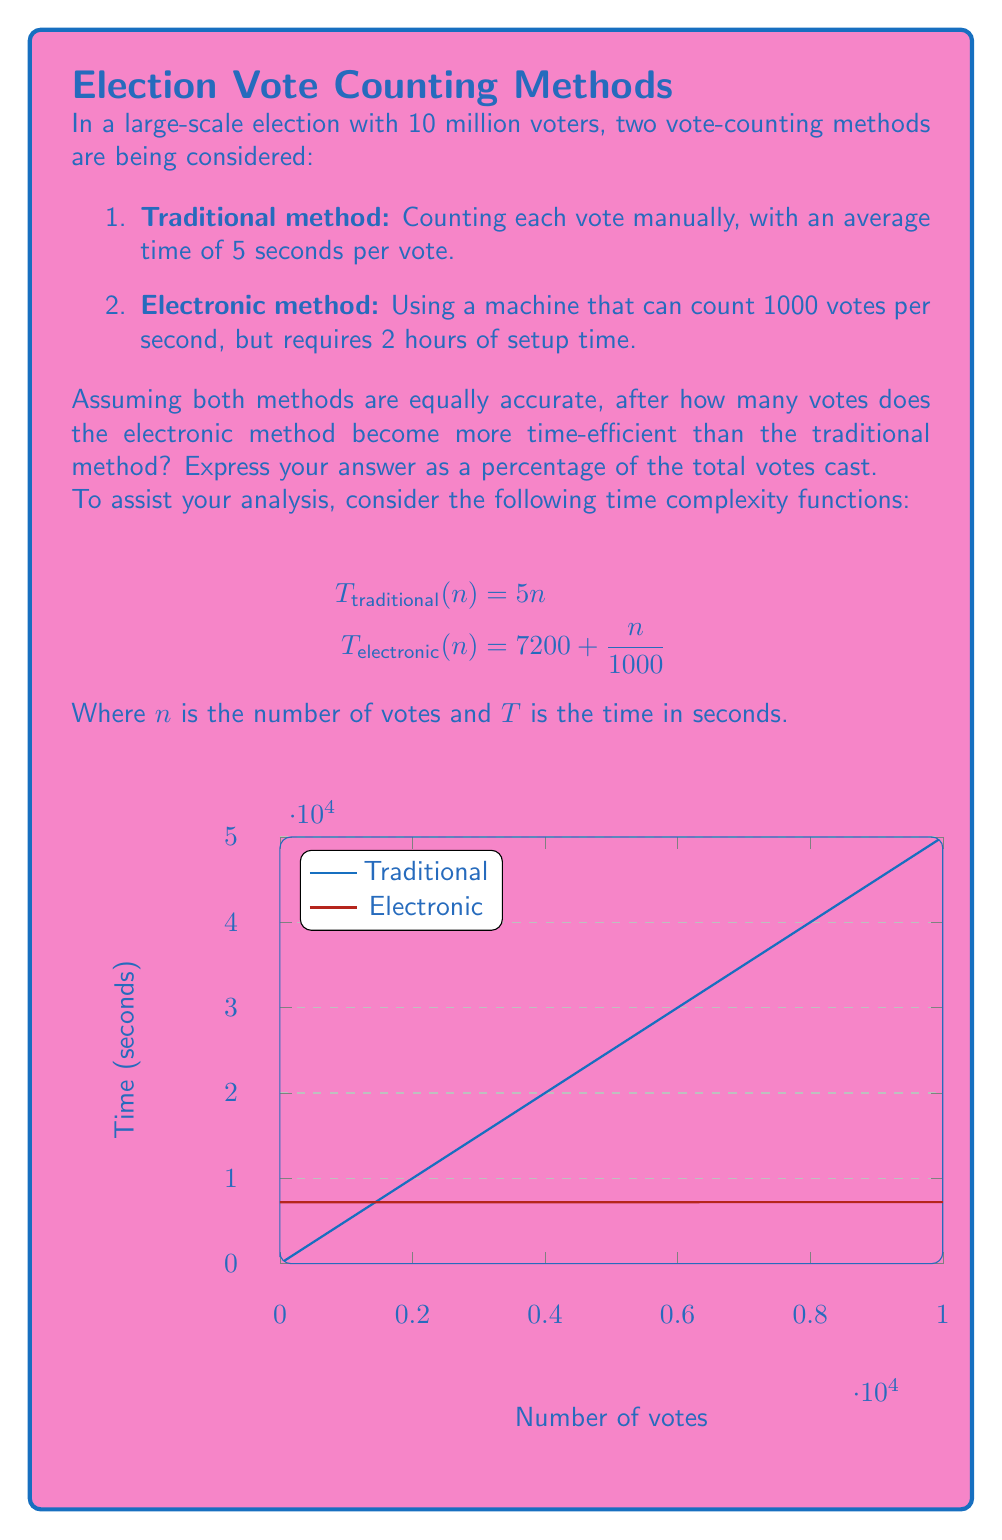What is the answer to this math problem? To find the point where the electronic method becomes more efficient, we need to set the two time complexity functions equal to each other and solve for $n$:

$$T_{traditional}(n) = T_{electronic}(n)$$
$$5n = 7200 + \frac{n}{1000}$$

Simplifying:
$$5000n = 7200000 + n$$
$$4999n = 7200000$$
$$n = \frac{7200000}{4999} \approx 1440.288$$

This means the electronic method becomes more efficient after 1441 votes (rounding up to the nearest whole vote).

To express this as a percentage of the total votes cast:

$$\text{Percentage} = \frac{1441}{10,000,000} \times 100\% = 0.01441\%$$

This result challenges the efficiency claims of electronic voting systems for small-scale elections, aligning with the skeptical perspective on technological solutions in democratic processes. However, it also demonstrates that for large-scale elections, electronic methods can significantly reduce counting time, potentially increasing transparency and reducing human error - aspects that a critical philosopher might find intriguing in the context of representative democracy.
Answer: $0.01441\%$ 